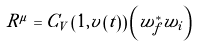Convert formula to latex. <formula><loc_0><loc_0><loc_500><loc_500>R ^ { \mu } = C _ { V } \left ( 1 , { v } \left ( t \right ) \right ) \left ( w _ { f } ^ { * } w _ { i } \right )</formula> 